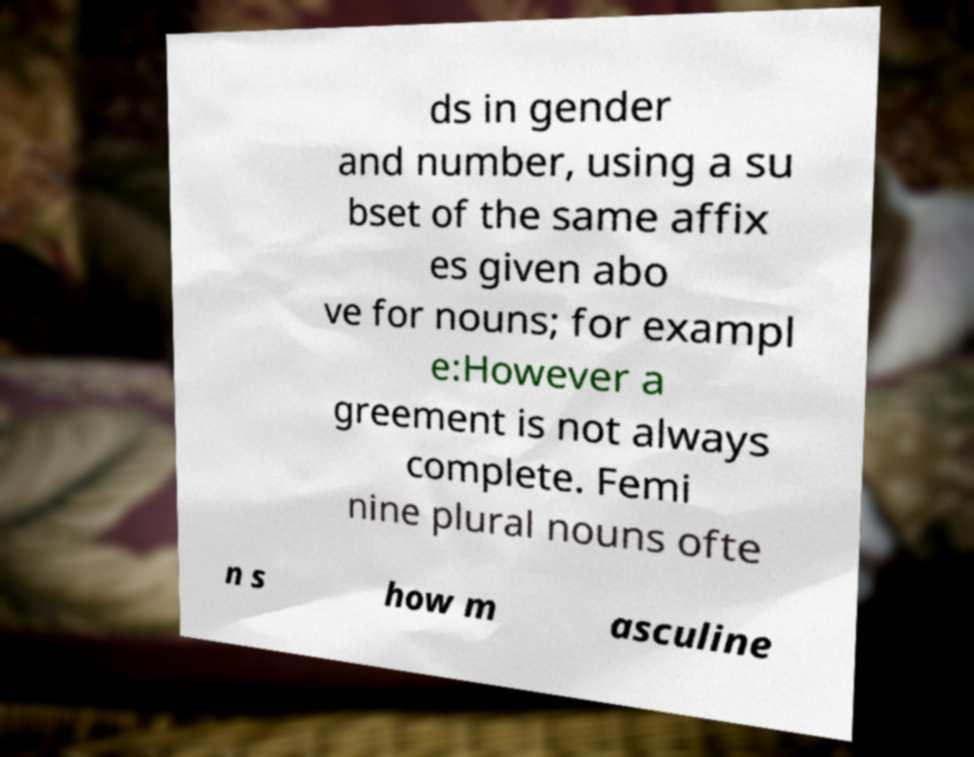Can you accurately transcribe the text from the provided image for me? ds in gender and number, using a su bset of the same affix es given abo ve for nouns; for exampl e:However a greement is not always complete. Femi nine plural nouns ofte n s how m asculine 